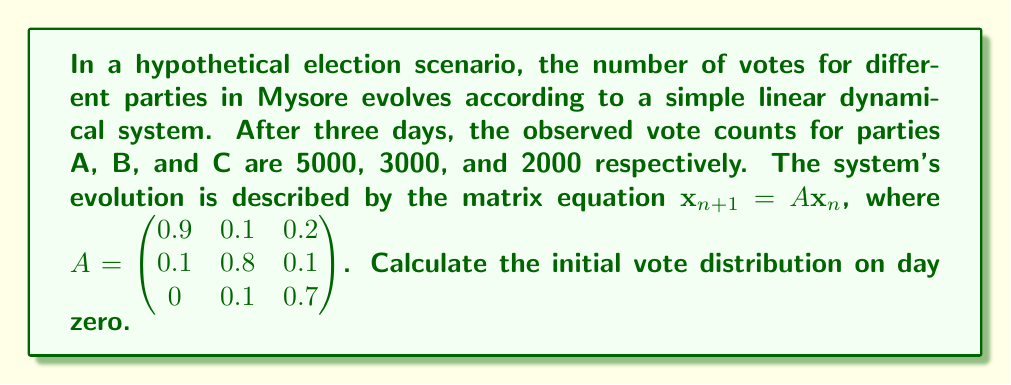Solve this math problem. To solve this inverse problem, we need to work backwards from the observed state to the initial state. Let's approach this step-by-step:

1) Let $\mathbf{x}_3 = \begin{pmatrix} 5000 \\ 3000 \\ 2000 \end{pmatrix}$ be the observed state after 3 days.

2) We need to find $\mathbf{x}_0$ such that $\mathbf{x}_3 = A^3\mathbf{x}_0$.

3) To do this, we need to calculate $A^3$ and then invert it:

   $A^3 = \begin{pmatrix} 0.9 & 0.1 & 0.2 \\ 0.1 & 0.8 & 0.1 \\ 0 & 0.1 & 0.7 \end{pmatrix}^3 = \begin{pmatrix} 0.756 & 0.244 & 0.388 \\ 0.227 & 0.571 & 0.253 \\ 0.017 & 0.185 & 0.359 \end{pmatrix}$

4) Now we can set up the equation:

   $\begin{pmatrix} 0.756 & 0.244 & 0.388 \\ 0.227 & 0.571 & 0.253 \\ 0.017 & 0.185 & 0.359 \end{pmatrix} \mathbf{x}_0 = \begin{pmatrix} 5000 \\ 3000 \\ 2000 \end{pmatrix}$

5) To solve for $\mathbf{x}_0$, we multiply both sides by the inverse of $A^3$:

   $\mathbf{x}_0 = (A^3)^{-1} \begin{pmatrix} 5000 \\ 3000 \\ 2000 \end{pmatrix}$

6) Calculating this:

   $\mathbf{x}_0 = \begin{pmatrix} 1.578 & -0.401 & -0.923 \\ -0.401 & 2.153 & -0.752 \\ -0.178 & -0.611 & 3.256 \end{pmatrix} \begin{pmatrix} 5000 \\ 3000 \\ 2000 \end{pmatrix} = \begin{pmatrix} 4052 \\ 2973 \\ 2975 \end{pmatrix}$

7) Rounding to the nearest whole number (as votes must be integers):

   $\mathbf{x}_0 \approx \begin{pmatrix} 4052 \\ 2973 \\ 2975 \end{pmatrix}$

Therefore, the initial vote distribution on day zero was approximately 4052 for party A, 2973 for party B, and 2975 for party C.
Answer: $\mathbf{x}_0 = \begin{pmatrix} 4052 \\ 2973 \\ 2975 \end{pmatrix}$ 